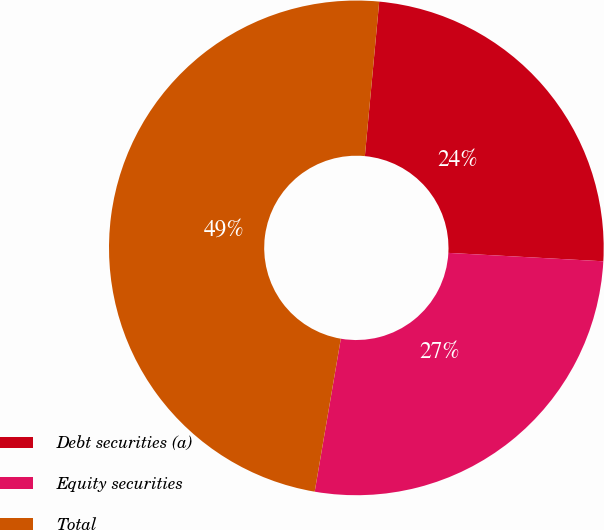<chart> <loc_0><loc_0><loc_500><loc_500><pie_chart><fcel>Debt securities (a)<fcel>Equity securities<fcel>Total<nl><fcel>24.39%<fcel>26.83%<fcel>48.78%<nl></chart> 